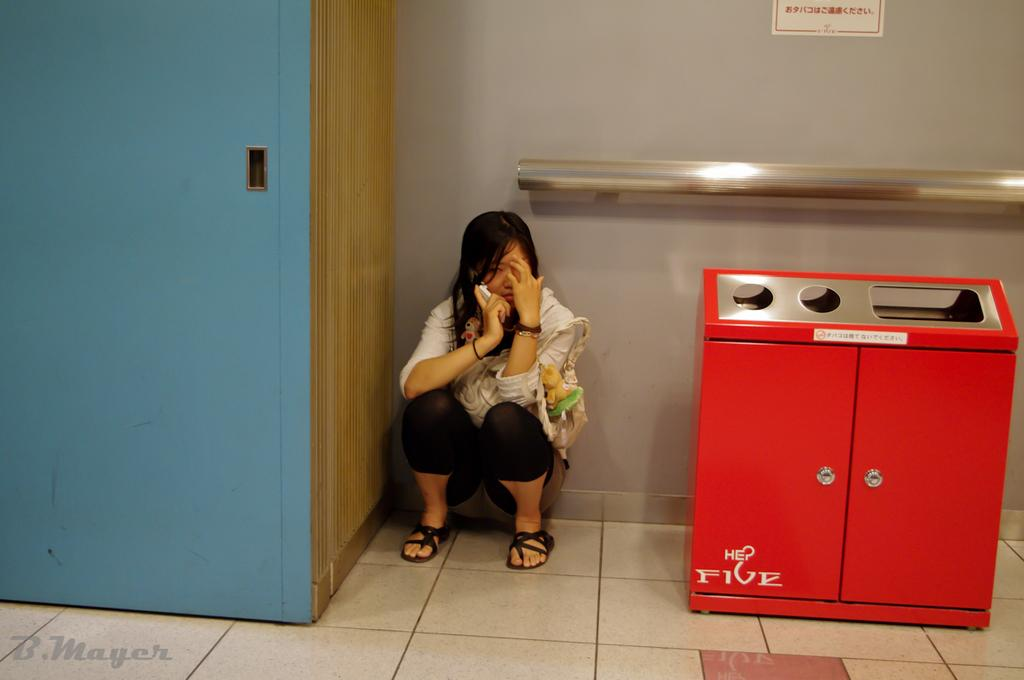<image>
Describe the image concisely. A red trash can has the word five on it near the bottom. 